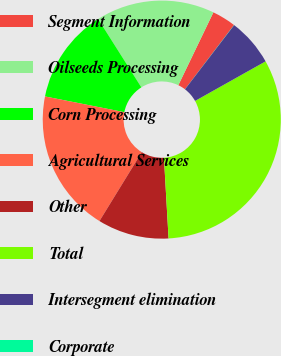Convert chart to OTSL. <chart><loc_0><loc_0><loc_500><loc_500><pie_chart><fcel>Segment Information<fcel>Oilseeds Processing<fcel>Corn Processing<fcel>Agricultural Services<fcel>Other<fcel>Total<fcel>Intersegment elimination<fcel>Corporate<nl><fcel>3.24%<fcel>16.12%<fcel>12.9%<fcel>19.35%<fcel>9.68%<fcel>32.23%<fcel>6.46%<fcel>0.02%<nl></chart> 